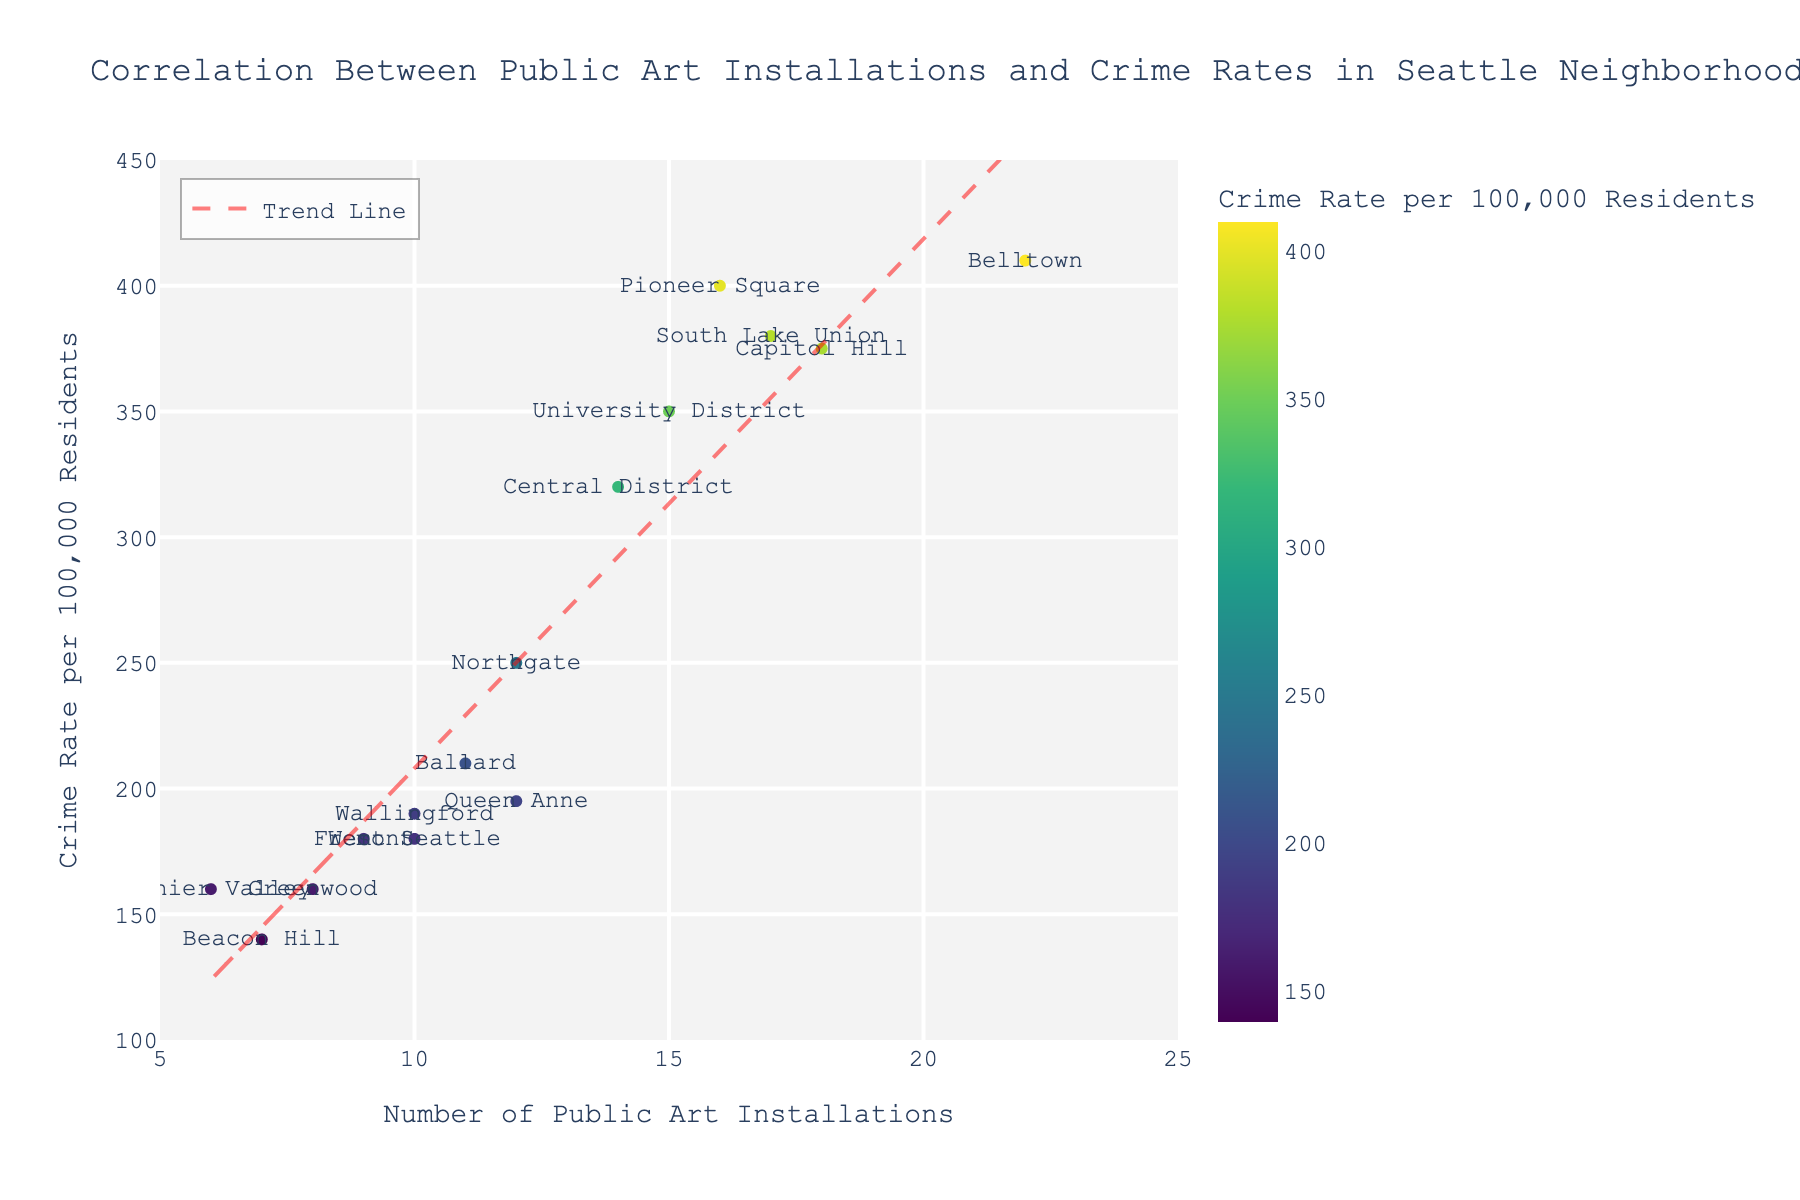What is the title of the plot? The title is typically found at the top of the plot, providing an overview of what the data represents. In this case, the title is "Correlation Between Public Art Installations and Crime Rates in Seattle Neighborhoods".
Answer: Correlation Between Public Art Installations and Crime Rates in Seattle Neighborhoods How many neighborhoods are represented in the plot? Count each data point labeled with neighborhood names. There are 15 data points, each representing a different neighborhood.
Answer: 15 Which neighborhood has the highest crime rate, and what is its corresponding number of public art installations? Identify the data point with the highest Y-axis value. Belltown has the highest crime rate at 410, and it has 22 public art installations.
Answer: Belltown, 22 Does the trend line show a positive or negative correlation between public art installations and crime rates? Observe the slope of the trend line. It has an upward slope indicating a positive correlation.
Answer: Positive What is the range of public art installations and crime rates in the neighborhoods? Examine the axes to find the minimum and maximum values for both Public Art Installations (X-axis) and Crime Rates (Y-axis). The range of public art installations is from 6 to 22, and the range of crime rates is from 140 to 410.
Answer: Public Art Installations: 6-22; Crime Rates: 140-410 Which neighborhood has the lowest number of public art installations, and what is its corresponding crime rate? Identify the data point with the lowest X-axis value. Rainier Valley has the lowest number of public art installations at 6, with a corresponding crime rate of 160.
Answer: Rainier Valley, 160 What is the average number of public art installations in Seattle neighborhoods? Sum the number of public art installations across all neighborhoods and divide by the number of neighborhoods (15). The sum is 177, divided by 15 gives an average of 11.8.
Answer: 11.8 Which neighborhoods have crime rates higher than 350? Identify data points with Y-axis values greater than 350. Belltown, Capitol Hill, Pioneer Square, South Lake Union, and University District have crime rates higher than 350.
Answer: Belltown, Capitol Hill, Pioneer Square, South Lake Union, University District What is the median crime rate among the neighborhoods? Arrange the crime rates in ascending order and find the middle value. The crime rates ordered are 140, 160, 160, 180, 180, 190, 195, 200, 210, 250, 320, 350, 375, 380, 400, 410. The median value is at the 8th and 9th positions, so the median is (200 + 210)/2 = 205.
Answer: 205 